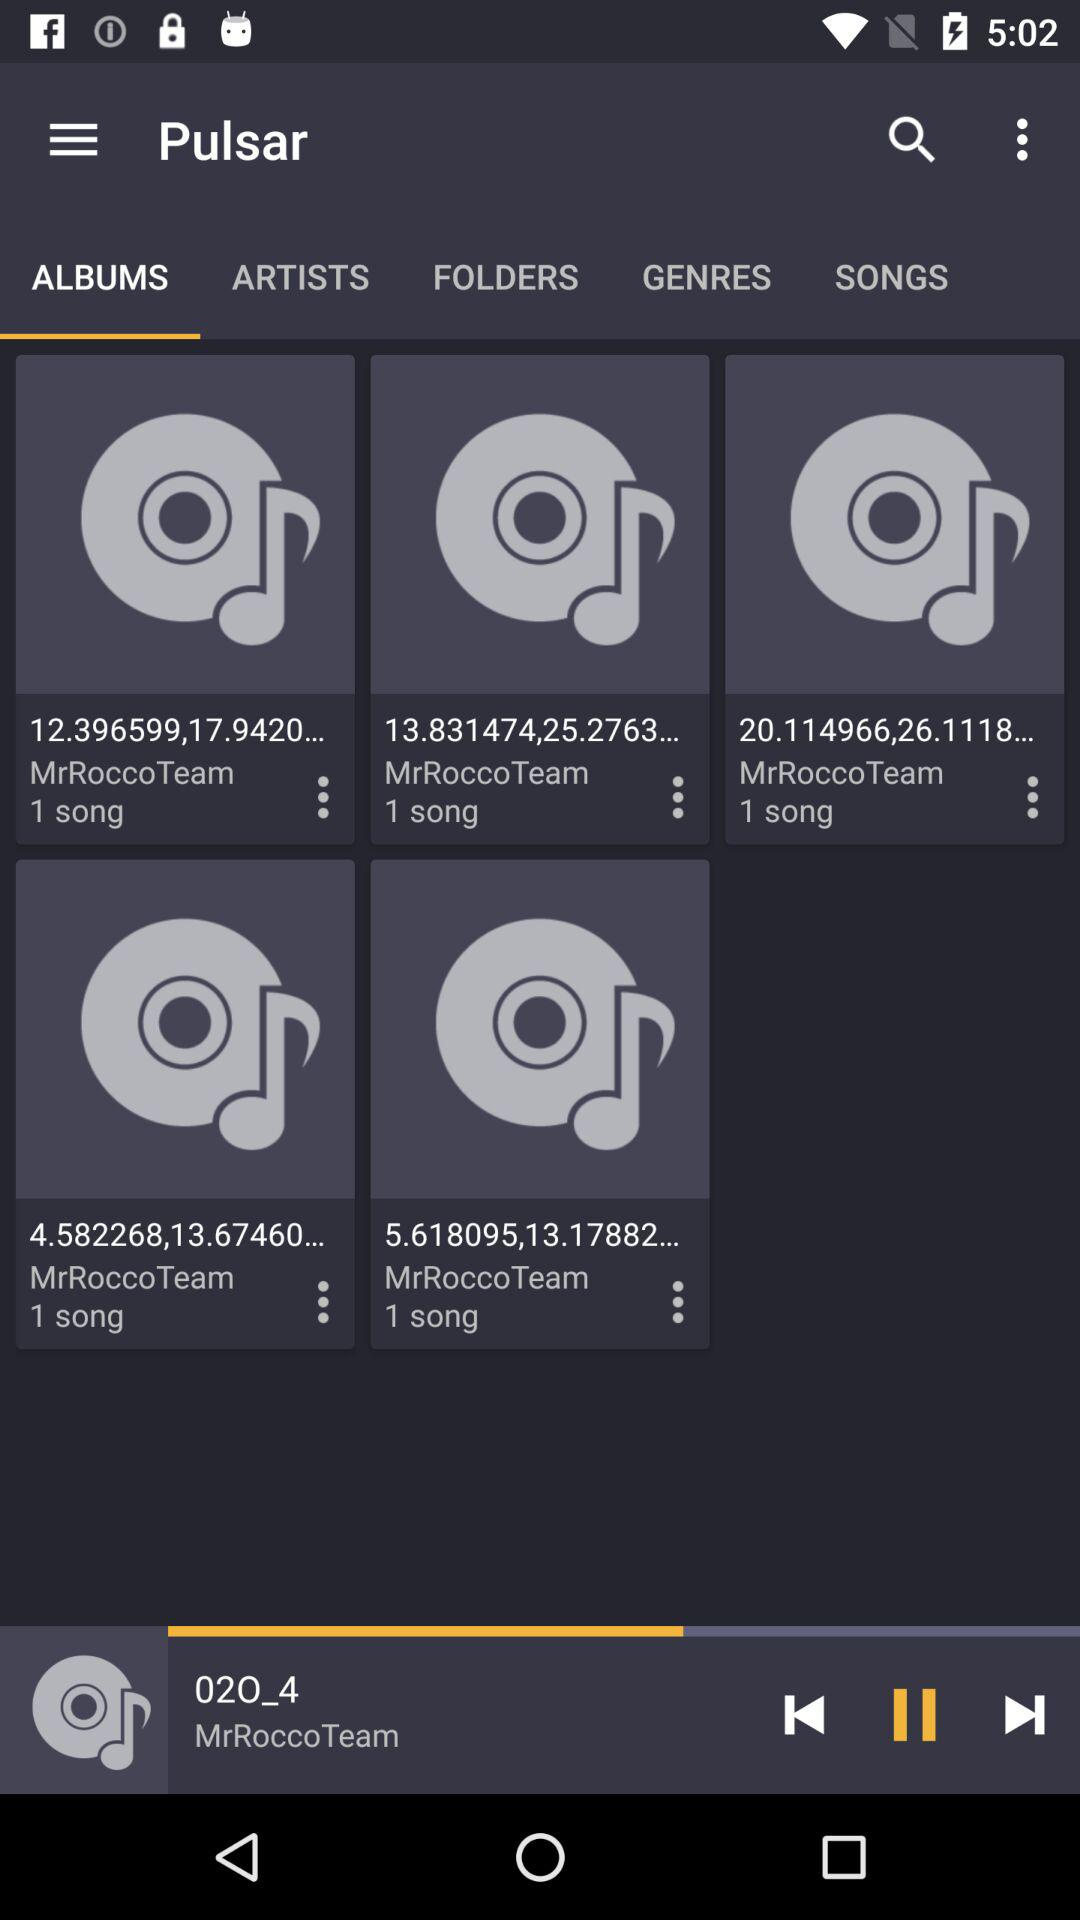What's the name of the current playing song whose artist is "MrRoccoTeam"? The name of the current playing song is "020_4". 